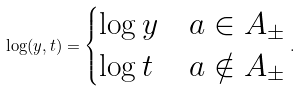Convert formula to latex. <formula><loc_0><loc_0><loc_500><loc_500>\log ( y , t ) = \begin{cases} \log y & a \in A _ { \pm } \\ \log t & a \notin A _ { \pm } \end{cases} .</formula> 